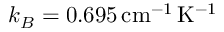Convert formula to latex. <formula><loc_0><loc_0><loc_500><loc_500>k _ { B } = 0 . 6 9 5 \, c m ^ { - 1 } \, K ^ { - 1 }</formula> 